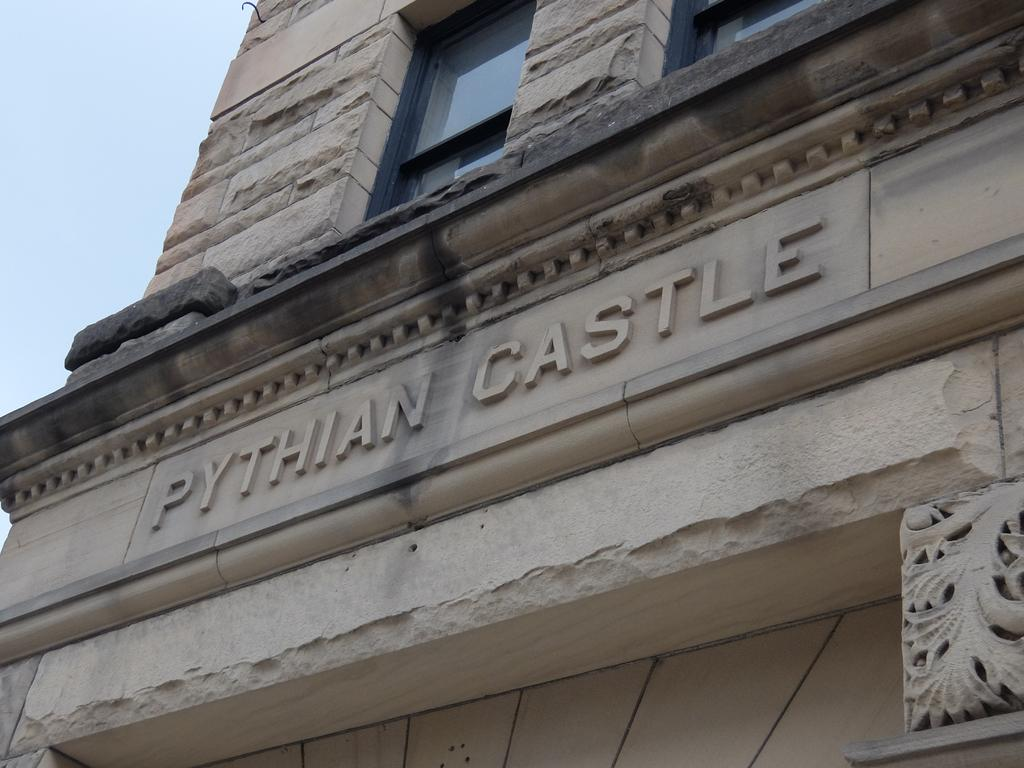What is the main structure in the image? There is a building in the image. What feature can be seen on the building? The building has windows. What is visible in the background of the image? The sky is visible in the image. How many balloons are tied to the front of the building in the image? There are no balloons present in the image, and therefore no such activity can be observed. 